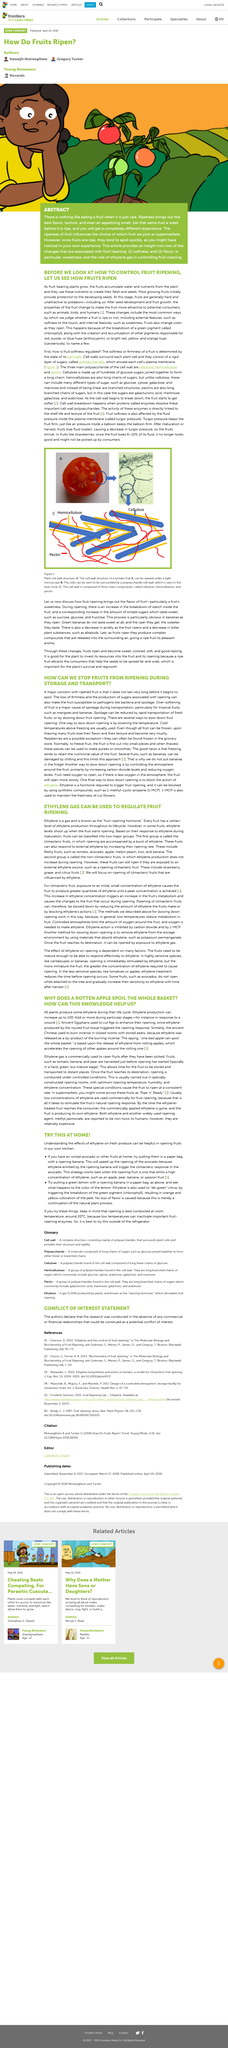Highlight a few significant elements in this photo. The presence of just one rotten apple in an entire basket can render the entire contents unfit for consumption. Yes, ripeness brings out the best flavor. Eating the same fruit a week before it is ripe will not give the same experience as eating it when it is ripe. The ripeness of fruit can influence shoppers' choices when selecting fruit to purchase. In ancient China, it was common practice to burn incense in a closed room while storing pears. 